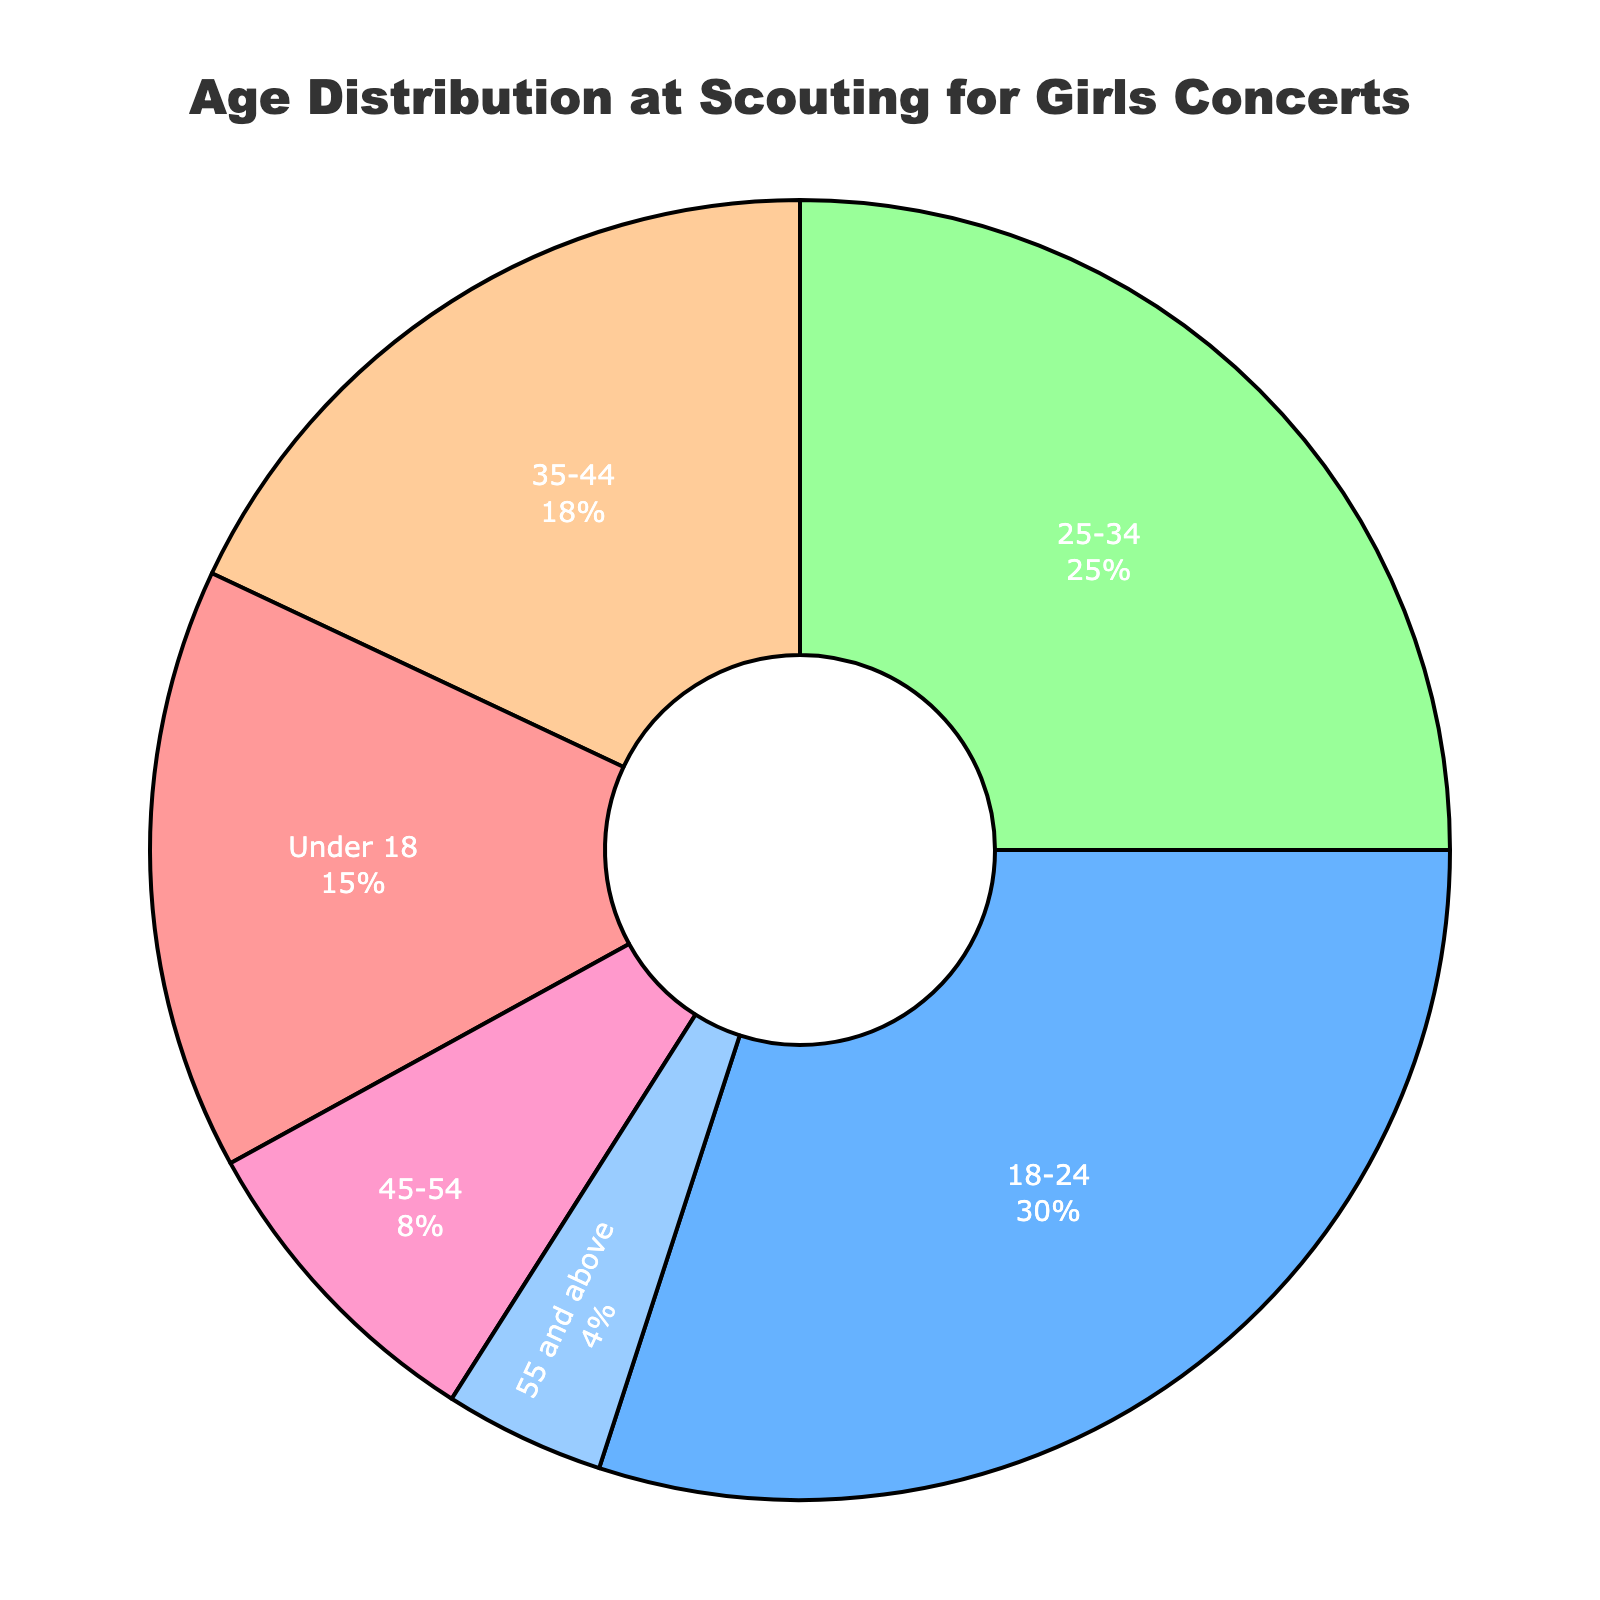What is the title of the figure? The title of the figure is displayed prominently at the top of the chart.
Answer: Age Distribution at Scouting for Girls Concerts Which age group has the highest percentage of attendees? Look for the largest segment in the pie chart. The 18-24 age group has the largest segment.
Answer: 18-24 What is the percentage of attendees aged 35-44? Locate the segment for ages 35-44 on the chart, and note the percentage displayed.
Answer: 18% Which color represents the 25-34 age group in the pie chart? Identify the segment labeled 25-34 and note the corresponding color.
Answer: Green (#99FF99) What is the sum of percentages for attendees under 18 and those aged 55 and above? Add the percentages for the Under 18 group (15%) and the 55 and above group (4%).
Answer: 19% How does the percentage of 45-54 attendees compare to that of 25-34 attendees? Compare the segment sizes or percentages directly from the chart, where 45-54 is 8% and 25-34 is 25%.
Answer: The percentage of 45-54 attendees is less than 25-34 attendees Which two age groups have the closest percentage of attendees, and what is the difference between them? Look at the chart segments to find the two closest percentages. 35-44 (18%) and Under 18 (15%) have the closest values.
Answer: 35-44 and Under 18; 3% Which age group contributes to exactly a quarter of the total attendees? Find the segment that marks 25% in the pie chart.
Answer: 25-34 What percentage of attendees are aged 18-44? Add the percentages for the 18-24 (30%), 25-34 (25%), and 35-44 (18%) age groups.
Answer: 73% If the concert had 1000 attendees, how many would be aged 45-54? Use the percentage for the 45-54 group (8%) and apply it to 1000 attendees. Calculate 8% of 1000.
Answer: 80 